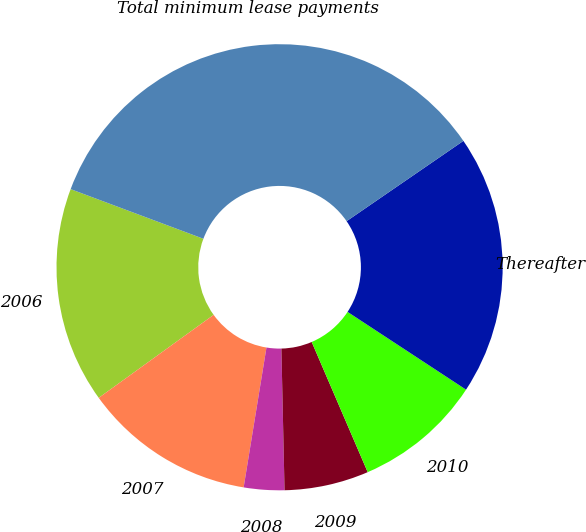<chart> <loc_0><loc_0><loc_500><loc_500><pie_chart><fcel>2006<fcel>2007<fcel>2008<fcel>2009<fcel>2010<fcel>Thereafter<fcel>Total minimum lease payments<nl><fcel>15.65%<fcel>12.47%<fcel>2.93%<fcel>6.11%<fcel>9.29%<fcel>18.83%<fcel>34.72%<nl></chart> 